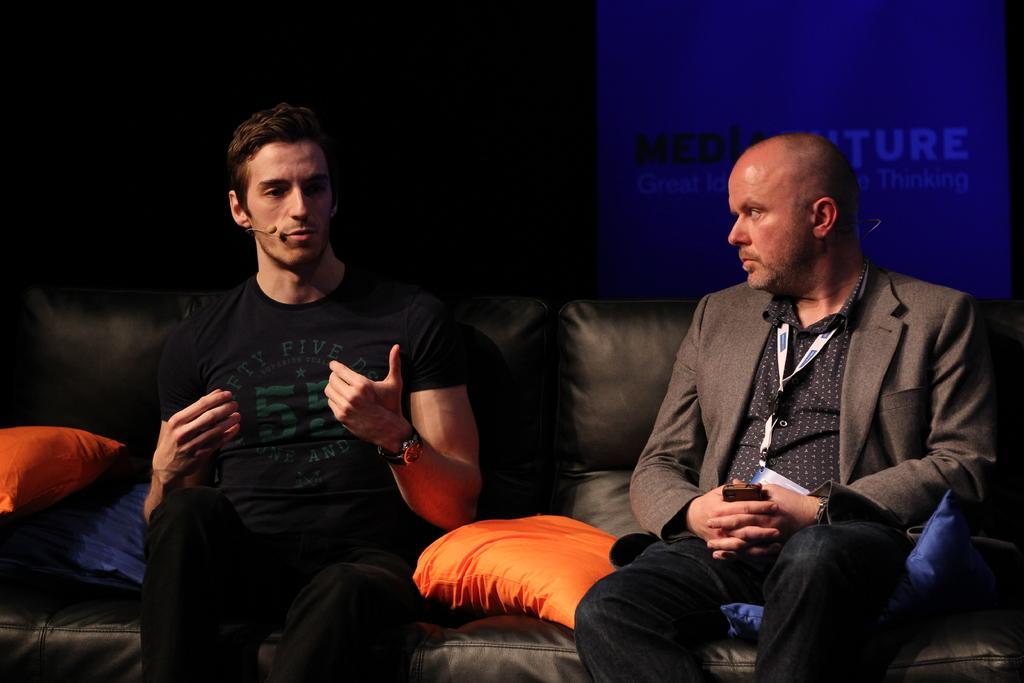Can you describe this image briefly? In this picture, we can see two persons with microphone sitting on sofa, and we can see some pillows on the sofa, we can see the dark background with poster and some text on it. 